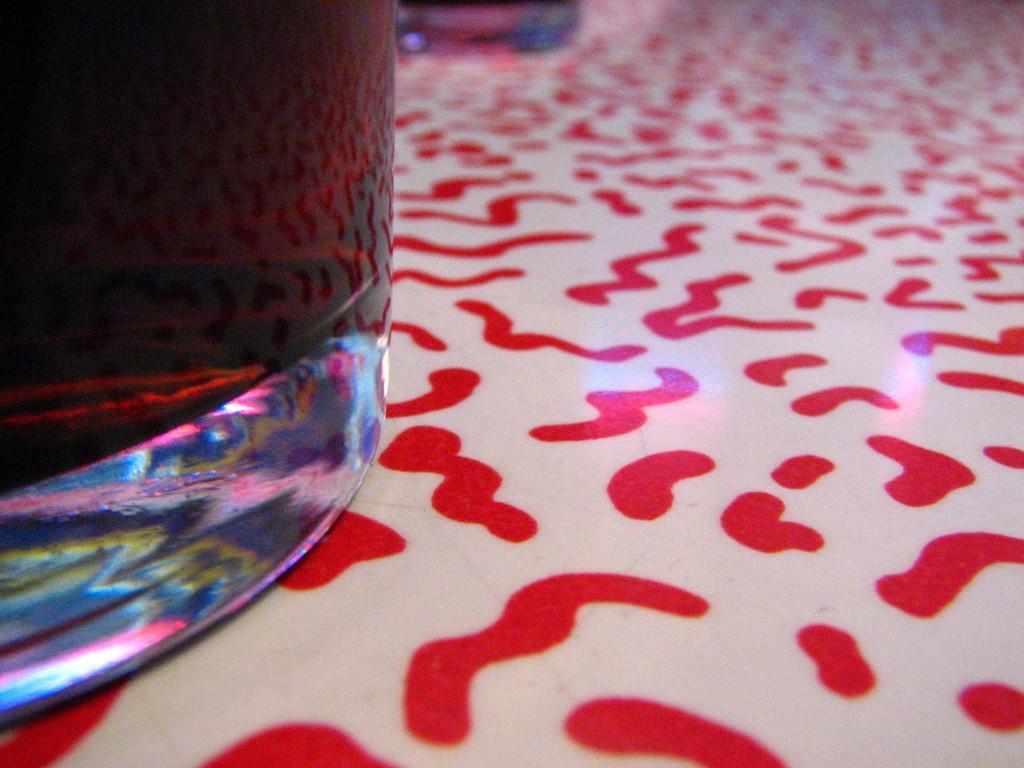Please provide a concise description of this image. In this picture we can see a glass on the left side, at the bottom we can see printed design. 